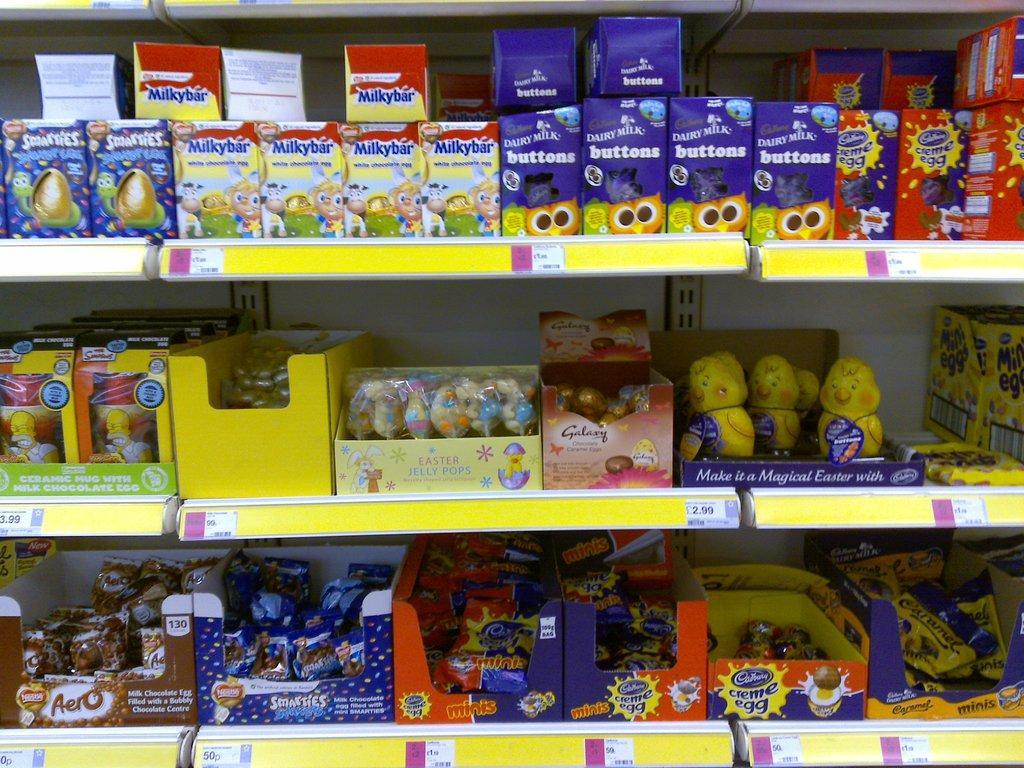How would you summarize this image in a sentence or two? In this image, we can see some shelves and food items on it. There are labels on each food item and price tags on shelves. 